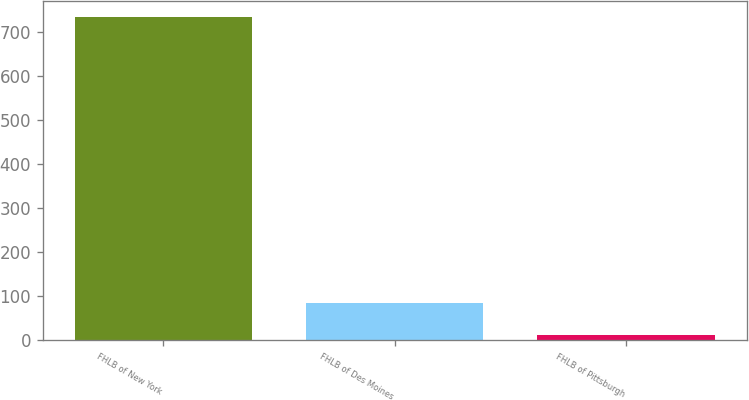Convert chart to OTSL. <chart><loc_0><loc_0><loc_500><loc_500><bar_chart><fcel>FHLB of New York<fcel>FHLB of Des Moines<fcel>FHLB of Pittsburgh<nl><fcel>733<fcel>83.2<fcel>11<nl></chart> 